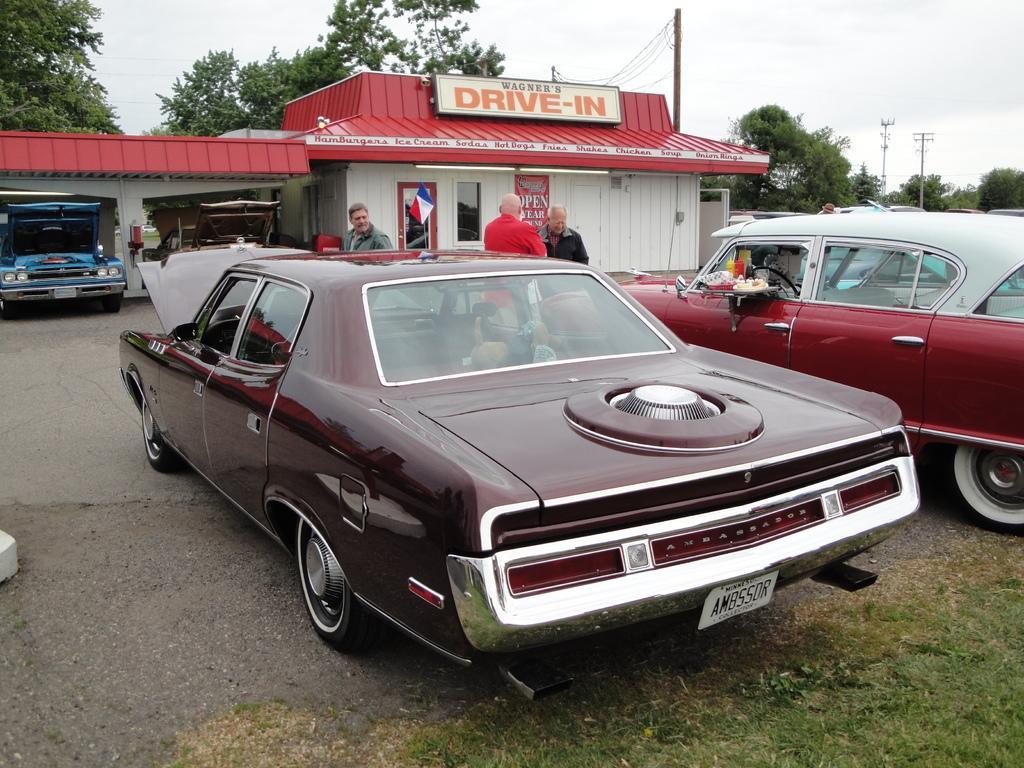In one or two sentences, can you explain what this image depicts? In this image there are vehicles on a pavement and there are people standing near the vehicle, in the background there is a garage, tree, poles and the sky. 